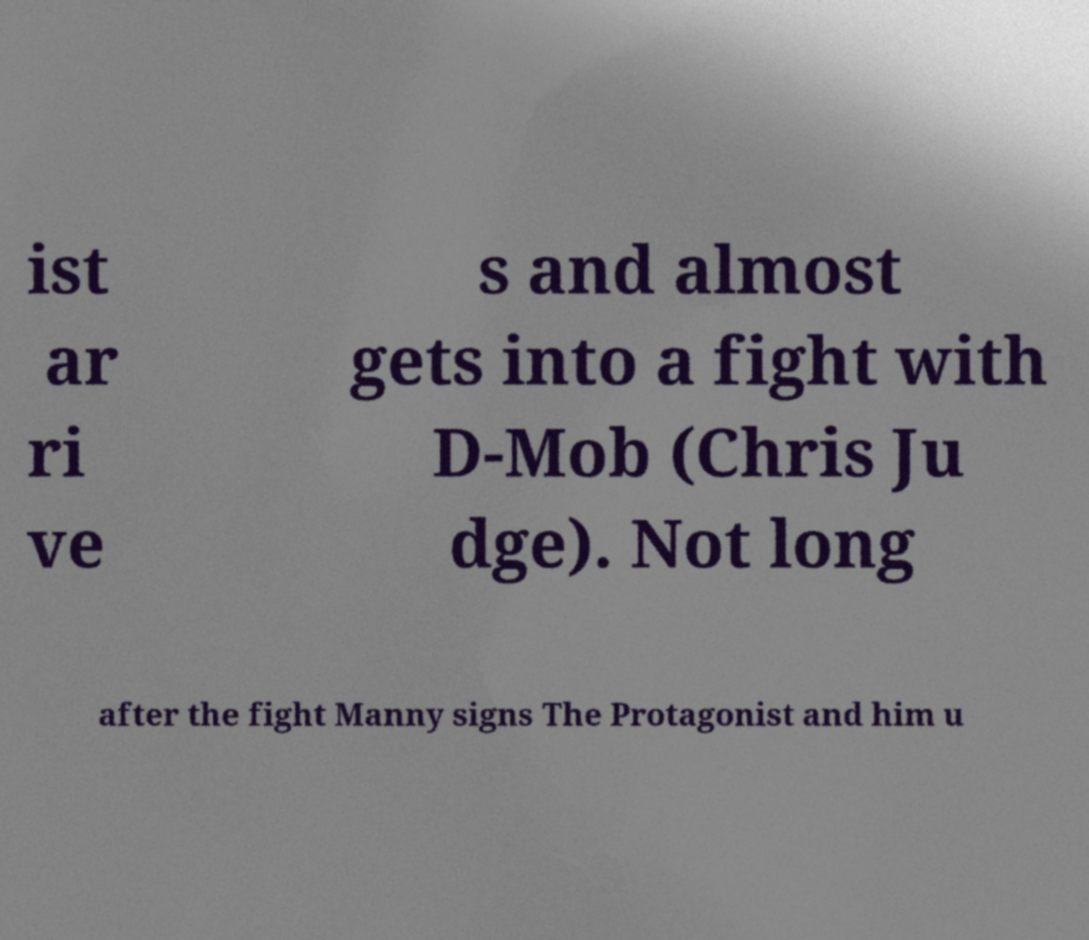I need the written content from this picture converted into text. Can you do that? ist ar ri ve s and almost gets into a fight with D-Mob (Chris Ju dge). Not long after the fight Manny signs The Protagonist and him u 